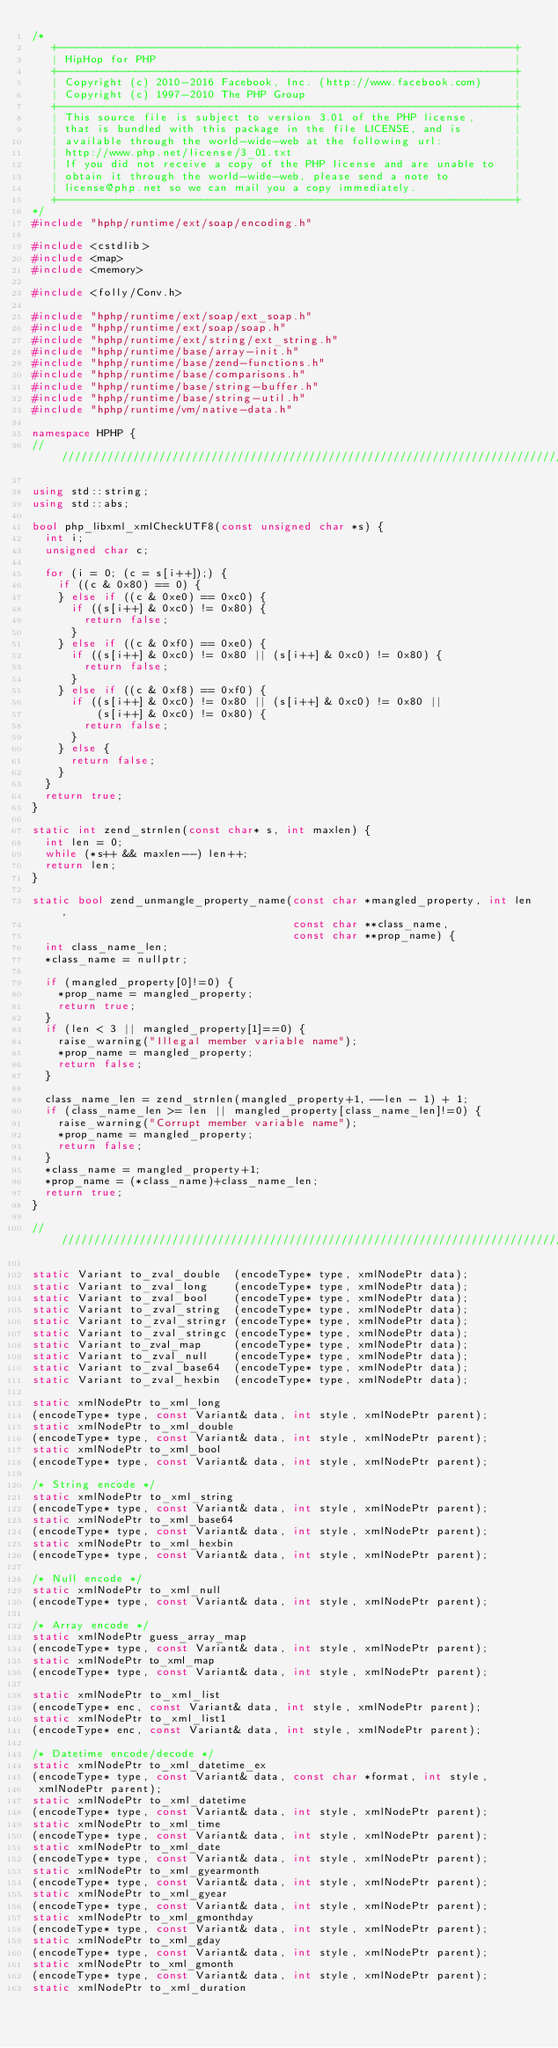<code> <loc_0><loc_0><loc_500><loc_500><_C++_>/*
   +----------------------------------------------------------------------+
   | HipHop for PHP                                                       |
   +----------------------------------------------------------------------+
   | Copyright (c) 2010-2016 Facebook, Inc. (http://www.facebook.com)     |
   | Copyright (c) 1997-2010 The PHP Group                                |
   +----------------------------------------------------------------------+
   | This source file is subject to version 3.01 of the PHP license,      |
   | that is bundled with this package in the file LICENSE, and is        |
   | available through the world-wide-web at the following url:           |
   | http://www.php.net/license/3_01.txt                                  |
   | If you did not receive a copy of the PHP license and are unable to   |
   | obtain it through the world-wide-web, please send a note to          |
   | license@php.net so we can mail you a copy immediately.               |
   +----------------------------------------------------------------------+
*/
#include "hphp/runtime/ext/soap/encoding.h"

#include <cstdlib>
#include <map>
#include <memory>

#include <folly/Conv.h>

#include "hphp/runtime/ext/soap/ext_soap.h"
#include "hphp/runtime/ext/soap/soap.h"
#include "hphp/runtime/ext/string/ext_string.h"
#include "hphp/runtime/base/array-init.h"
#include "hphp/runtime/base/zend-functions.h"
#include "hphp/runtime/base/comparisons.h"
#include "hphp/runtime/base/string-buffer.h"
#include "hphp/runtime/base/string-util.h"
#include "hphp/runtime/vm/native-data.h"

namespace HPHP {
///////////////////////////////////////////////////////////////////////////////

using std::string;
using std::abs;

bool php_libxml_xmlCheckUTF8(const unsigned char *s) {
  int i;
  unsigned char c;

  for (i = 0; (c = s[i++]);) {
    if ((c & 0x80) == 0) {
    } else if ((c & 0xe0) == 0xc0) {
      if ((s[i++] & 0xc0) != 0x80) {
        return false;
      }
    } else if ((c & 0xf0) == 0xe0) {
      if ((s[i++] & 0xc0) != 0x80 || (s[i++] & 0xc0) != 0x80) {
        return false;
      }
    } else if ((c & 0xf8) == 0xf0) {
      if ((s[i++] & 0xc0) != 0x80 || (s[i++] & 0xc0) != 0x80 ||
          (s[i++] & 0xc0) != 0x80) {
        return false;
      }
    } else {
      return false;
    }
  }
  return true;
}

static int zend_strnlen(const char* s, int maxlen) {
  int len = 0;
  while (*s++ && maxlen--) len++;
  return len;
}

static bool zend_unmangle_property_name(const char *mangled_property, int len,
                                        const char **class_name,
                                        const char **prop_name) {
  int class_name_len;
  *class_name = nullptr;

  if (mangled_property[0]!=0) {
    *prop_name = mangled_property;
    return true;
  }
  if (len < 3 || mangled_property[1]==0) {
    raise_warning("Illegal member variable name");
    *prop_name = mangled_property;
    return false;
  }

  class_name_len = zend_strnlen(mangled_property+1, --len - 1) + 1;
  if (class_name_len >= len || mangled_property[class_name_len]!=0) {
    raise_warning("Corrupt member variable name");
    *prop_name = mangled_property;
    return false;
  }
  *class_name = mangled_property+1;
  *prop_name = (*class_name)+class_name_len;
  return true;
}

///////////////////////////////////////////////////////////////////////////////

static Variant to_zval_double  (encodeType* type, xmlNodePtr data);
static Variant to_zval_long    (encodeType* type, xmlNodePtr data);
static Variant to_zval_bool    (encodeType* type, xmlNodePtr data);
static Variant to_zval_string  (encodeType* type, xmlNodePtr data);
static Variant to_zval_stringr (encodeType* type, xmlNodePtr data);
static Variant to_zval_stringc (encodeType* type, xmlNodePtr data);
static Variant to_zval_map     (encodeType* type, xmlNodePtr data);
static Variant to_zval_null    (encodeType* type, xmlNodePtr data);
static Variant to_zval_base64  (encodeType* type, xmlNodePtr data);
static Variant to_zval_hexbin  (encodeType* type, xmlNodePtr data);

static xmlNodePtr to_xml_long
(encodeType* type, const Variant& data, int style, xmlNodePtr parent);
static xmlNodePtr to_xml_double
(encodeType* type, const Variant& data, int style, xmlNodePtr parent);
static xmlNodePtr to_xml_bool
(encodeType* type, const Variant& data, int style, xmlNodePtr parent);

/* String encode */
static xmlNodePtr to_xml_string
(encodeType* type, const Variant& data, int style, xmlNodePtr parent);
static xmlNodePtr to_xml_base64
(encodeType* type, const Variant& data, int style, xmlNodePtr parent);
static xmlNodePtr to_xml_hexbin
(encodeType* type, const Variant& data, int style, xmlNodePtr parent);

/* Null encode */
static xmlNodePtr to_xml_null
(encodeType* type, const Variant& data, int style, xmlNodePtr parent);

/* Array encode */
static xmlNodePtr guess_array_map
(encodeType* type, const Variant& data, int style, xmlNodePtr parent);
static xmlNodePtr to_xml_map
(encodeType* type, const Variant& data, int style, xmlNodePtr parent);

static xmlNodePtr to_xml_list
(encodeType* enc, const Variant& data, int style, xmlNodePtr parent);
static xmlNodePtr to_xml_list1
(encodeType* enc, const Variant& data, int style, xmlNodePtr parent);

/* Datetime encode/decode */
static xmlNodePtr to_xml_datetime_ex
(encodeType* type, const Variant& data, const char *format, int style,
 xmlNodePtr parent);
static xmlNodePtr to_xml_datetime
(encodeType* type, const Variant& data, int style, xmlNodePtr parent);
static xmlNodePtr to_xml_time
(encodeType* type, const Variant& data, int style, xmlNodePtr parent);
static xmlNodePtr to_xml_date
(encodeType* type, const Variant& data, int style, xmlNodePtr parent);
static xmlNodePtr to_xml_gyearmonth
(encodeType* type, const Variant& data, int style, xmlNodePtr parent);
static xmlNodePtr to_xml_gyear
(encodeType* type, const Variant& data, int style, xmlNodePtr parent);
static xmlNodePtr to_xml_gmonthday
(encodeType* type, const Variant& data, int style, xmlNodePtr parent);
static xmlNodePtr to_xml_gday
(encodeType* type, const Variant& data, int style, xmlNodePtr parent);
static xmlNodePtr to_xml_gmonth
(encodeType* type, const Variant& data, int style, xmlNodePtr parent);
static xmlNodePtr to_xml_duration</code> 